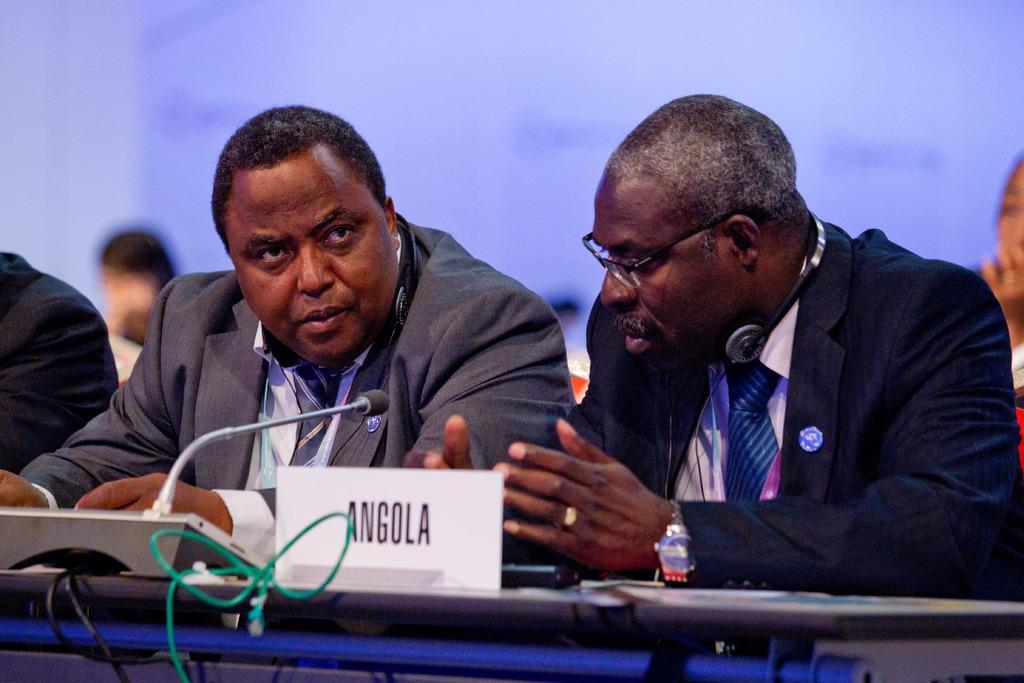Can you describe this image briefly? In the center of the image we can see people sitting. They are wearing suits. At the bottom there is a table and we can see a mic and a name board placed on the table. In the background there is a wall. 